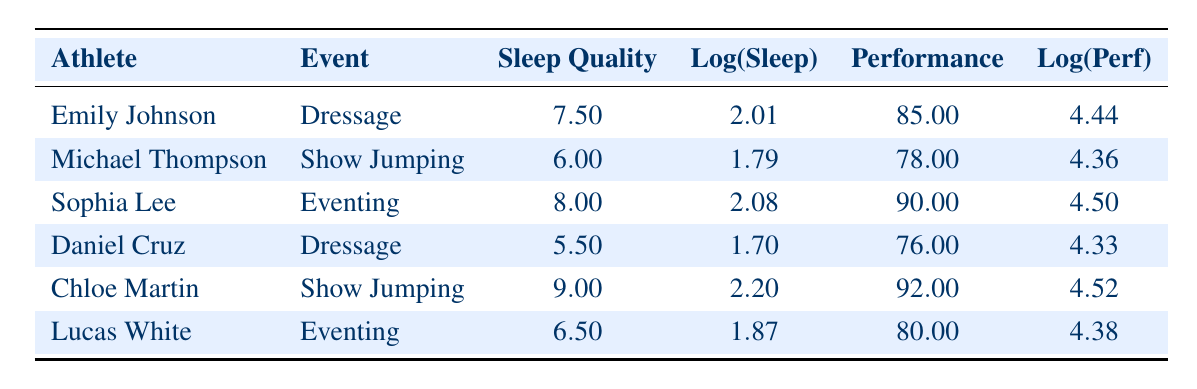What is the performance score of Sophia Lee in Eventing? From the table, Sophia Lee is listed under the Eventing category with a performance score of 90.
Answer: 90 Which athlete had the highest sleep quality and what was that value? Reviewing the table, Chloe Martin shows the highest sleep quality score of 9.0 compared to other athletes.
Answer: 9.0 What is the difference in performance scores between Emily Johnson and Daniel Cruz? Emily Johnson has a performance score of 85, and Daniel Cruz has a score of 76. The difference is calculated as 85 - 76 = 9.
Answer: 9 Is there any athlete who performed better than 90? The table shows that the highest performance score is 92, achieved by Chloe Martin, hence there is an athlete who performed better than 90.
Answer: Yes What is the average sleep quality for all athletes in the table? To find the average: add the sleep quality values: (7.5 + 6.0 + 8.0 + 5.5 + 9.0 + 6.5) = 42.5. Divide by the number of athletes (6), which equals 42.5 / 6 = 7.08.
Answer: 7.08 Which event had the lowest performance score and what was the score? According to the table, Daniel Cruz in Dressage achieved the lowest performance score of 76 among all athletes.
Answer: 76 Is Michael Thompson's sleep quality higher than Lucas White's? The table indicates that Michael Thompson has a sleep quality score of 6.0 and Lucas White has a score of 6.5. Since 6.0 is not higher than 6.5, the answer is no.
Answer: No What are the logged values of sleep quality for the athlete with the lowest performance score? Daniel Cruz has the lowest performance score of 76 and his sleep quality value is 5.5. The log of 5.5 is approximately 1.70, as seen in the table.
Answer: 1.70 What is the combined performance score of all athletes in Eventing? The performance scores for the Eventing athletes are 90 (Sophia Lee) and 80 (Lucas White). Adding these together gives: 90 + 80 = 170.
Answer: 170 